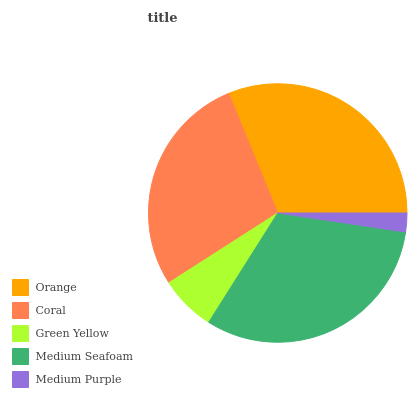Is Medium Purple the minimum?
Answer yes or no. Yes. Is Medium Seafoam the maximum?
Answer yes or no. Yes. Is Coral the minimum?
Answer yes or no. No. Is Coral the maximum?
Answer yes or no. No. Is Orange greater than Coral?
Answer yes or no. Yes. Is Coral less than Orange?
Answer yes or no. Yes. Is Coral greater than Orange?
Answer yes or no. No. Is Orange less than Coral?
Answer yes or no. No. Is Coral the high median?
Answer yes or no. Yes. Is Coral the low median?
Answer yes or no. Yes. Is Medium Seafoam the high median?
Answer yes or no. No. Is Medium Seafoam the low median?
Answer yes or no. No. 